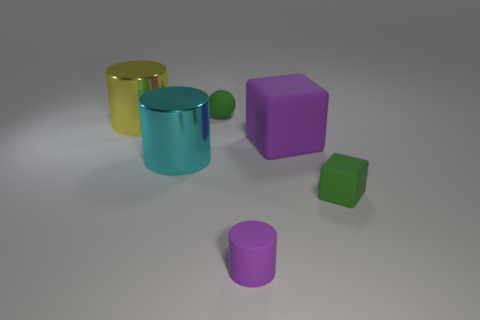Subtract all rubber cylinders. How many cylinders are left? 2 Subtract 1 cubes. How many cubes are left? 1 Subtract all purple cubes. How many cubes are left? 1 Add 3 brown metallic balls. How many objects exist? 9 Subtract all blue cylinders. Subtract all purple cubes. How many cylinders are left? 3 Subtract all tiny gray blocks. Subtract all tiny purple matte objects. How many objects are left? 5 Add 5 green spheres. How many green spheres are left? 6 Add 4 blue balls. How many blue balls exist? 4 Subtract 1 yellow cylinders. How many objects are left? 5 Subtract all blocks. How many objects are left? 4 